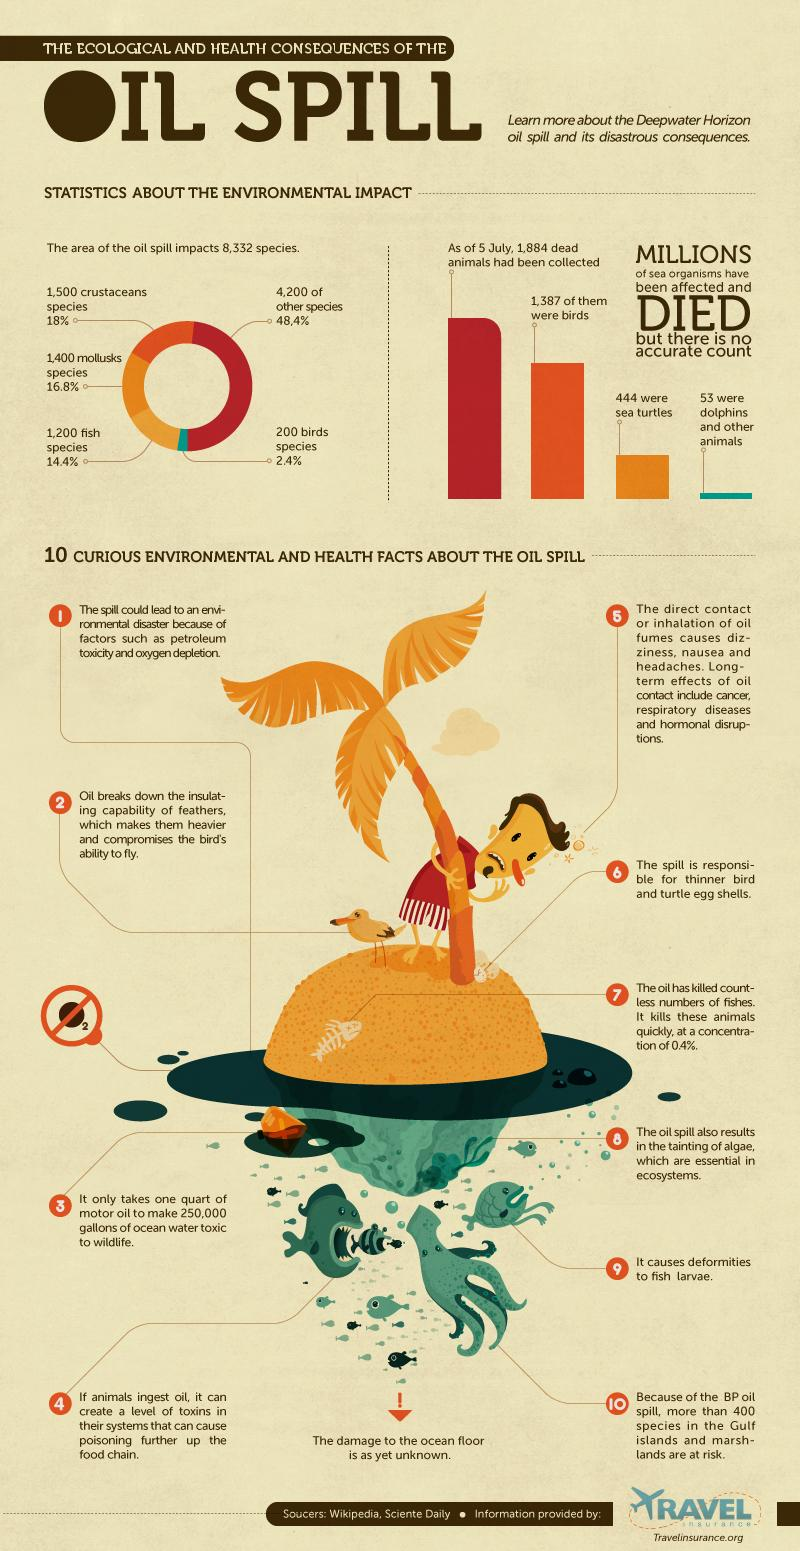Draw attention to some important aspects in this diagram. The ninth fact in the list is that oil spills can cause deformities in fish larvae. The total number of crustacean and mollusk species that are being affected by the oil spill is 2,900. Approximately 31.2% of fish and mollusk species are affected by oil spills. As of July 5, there were 497 dead animals other than birds that had been collected. A recent study has found that among all the species affected by oil spills, 34.8% are crustaceans and mollusk species. 